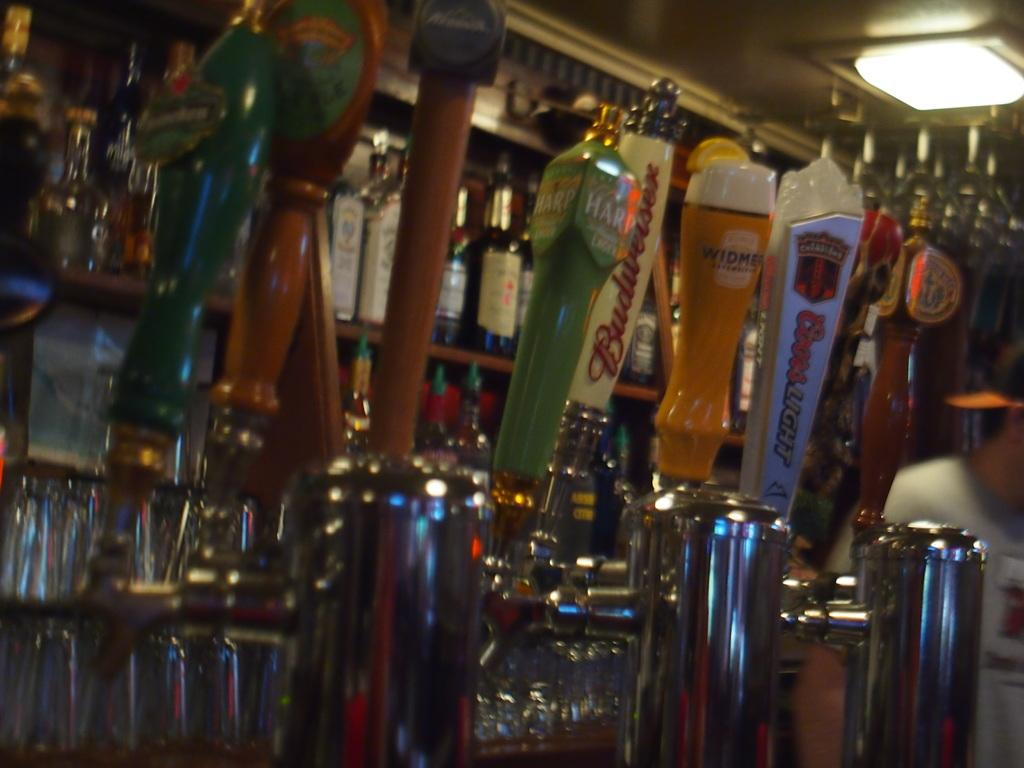<image>
Create a compact narrative representing the image presented. Bar tavern with different beer labels and bottles on the shelf, budweiser, and coors light. 